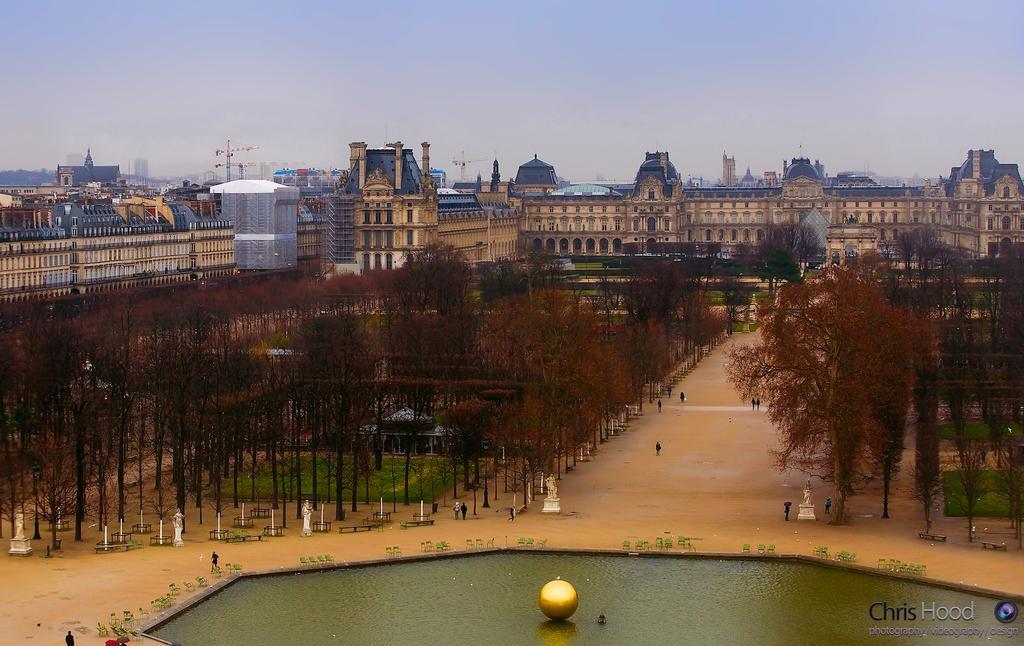How would you summarize this image in a sentence or two? In this image in the center there are some buildings, towers poles and in the foreground there are some trees and some persons are walking on a walkway. At the bottom there is a fountain, and at the top of the image there is sky. 